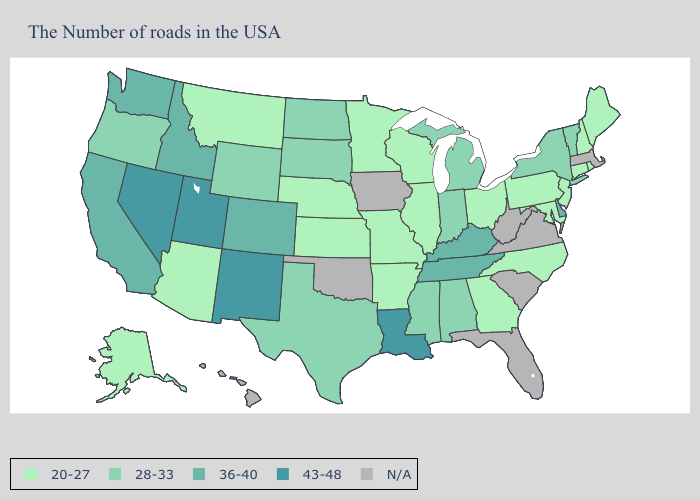What is the value of Mississippi?
Keep it brief. 28-33. What is the lowest value in the South?
Give a very brief answer. 20-27. Name the states that have a value in the range N/A?
Be succinct. Massachusetts, Virginia, South Carolina, West Virginia, Florida, Iowa, Oklahoma, Hawaii. What is the value of Nevada?
Concise answer only. 43-48. What is the lowest value in the South?
Short answer required. 20-27. What is the value of Indiana?
Short answer required. 28-33. Among the states that border Ohio , which have the lowest value?
Short answer required. Pennsylvania. Among the states that border Kansas , does Colorado have the highest value?
Write a very short answer. Yes. Among the states that border Wisconsin , does Michigan have the lowest value?
Quick response, please. No. What is the value of Washington?
Give a very brief answer. 36-40. Is the legend a continuous bar?
Concise answer only. No. Is the legend a continuous bar?
Be succinct. No. Among the states that border Missouri , which have the highest value?
Concise answer only. Kentucky, Tennessee. Among the states that border Ohio , does Pennsylvania have the lowest value?
Quick response, please. Yes. What is the lowest value in states that border Alabama?
Write a very short answer. 20-27. 